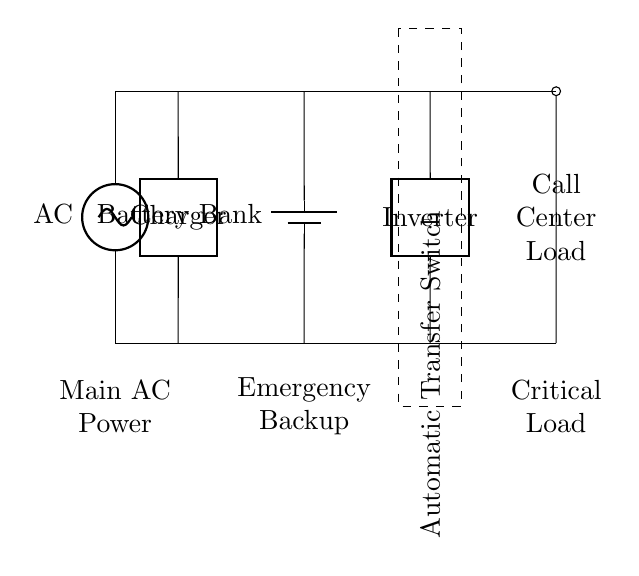What type of power supply is this circuit using? The circuit uses an AC power supply, indicated by the symbol on the left side of the diagram. It is labeled as AC.
Answer: AC What is the role of the battery bank in this circuit? The battery bank serves as an emergency backup, providing power when the main AC supply is unavailable. It is marked as Battery Bank in the diagram.
Answer: Emergency backup What component connects the AC power supply to the battery charger? The charger connects these two components, shown as a two-port device between the AC supply and the battery bank.
Answer: Charger How many main components are there in this circuit? Counting the main components in the circuit, we have the AC supply, charger, battery bank, inverter, automatic transfer switch, and load. This totals to six main components.
Answer: Six What happens if the main AC power fails? In the event of a failure, the automatic transfer switch allows the inverter to supply power from the battery bank to the load, ensuring continuous operation. This action is inferred from the function of the automatic transfer switch connected to both the inverter and the load.
Answer: Continuous operation Which component is responsible for converting DC to AC? The inverter is responsible for this conversion, as it converts the direct current from the battery bank to alternating current for the load as shown in the circuit.
Answer: Inverter What does the dashed rectangle represent in the circuit diagram? The dashed rectangle encompasses the automatic transfer switch, indicating that it is a boundary that separates it from the other components. This switch ensures seamless transfer of power to the load.
Answer: Automatic Transfer Switch 